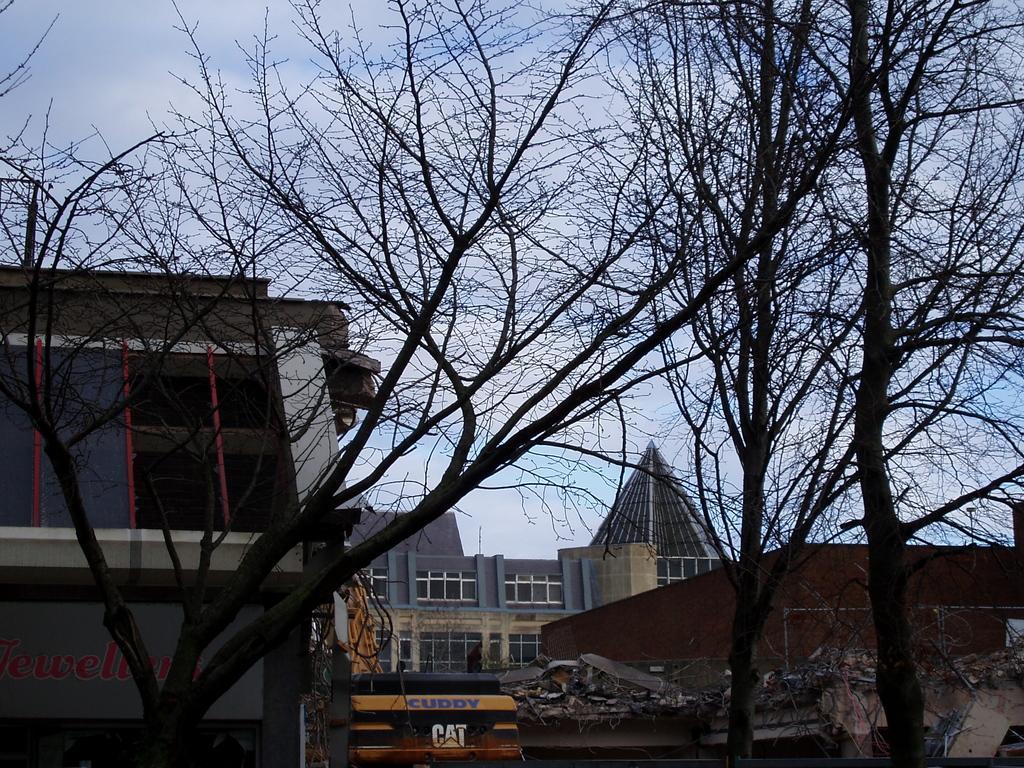In one or two sentences, can you explain what this image depicts? In this picture we can see trees, buildings and vehicle. In the background of the image we can see the sky. 